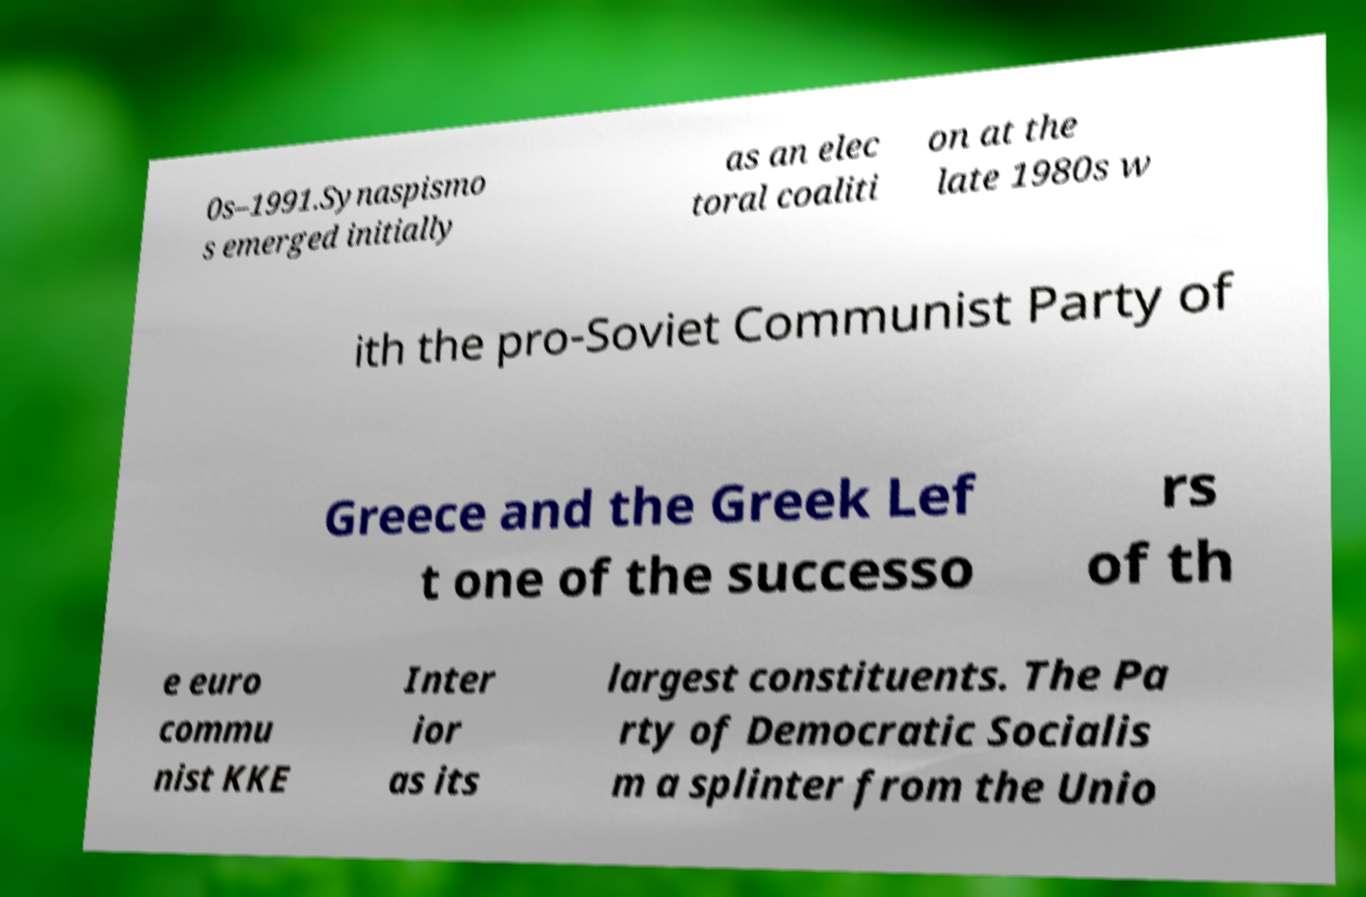Please read and relay the text visible in this image. What does it say? 0s–1991.Synaspismo s emerged initially as an elec toral coaliti on at the late 1980s w ith the pro-Soviet Communist Party of Greece and the Greek Lef t one of the successo rs of th e euro commu nist KKE Inter ior as its largest constituents. The Pa rty of Democratic Socialis m a splinter from the Unio 